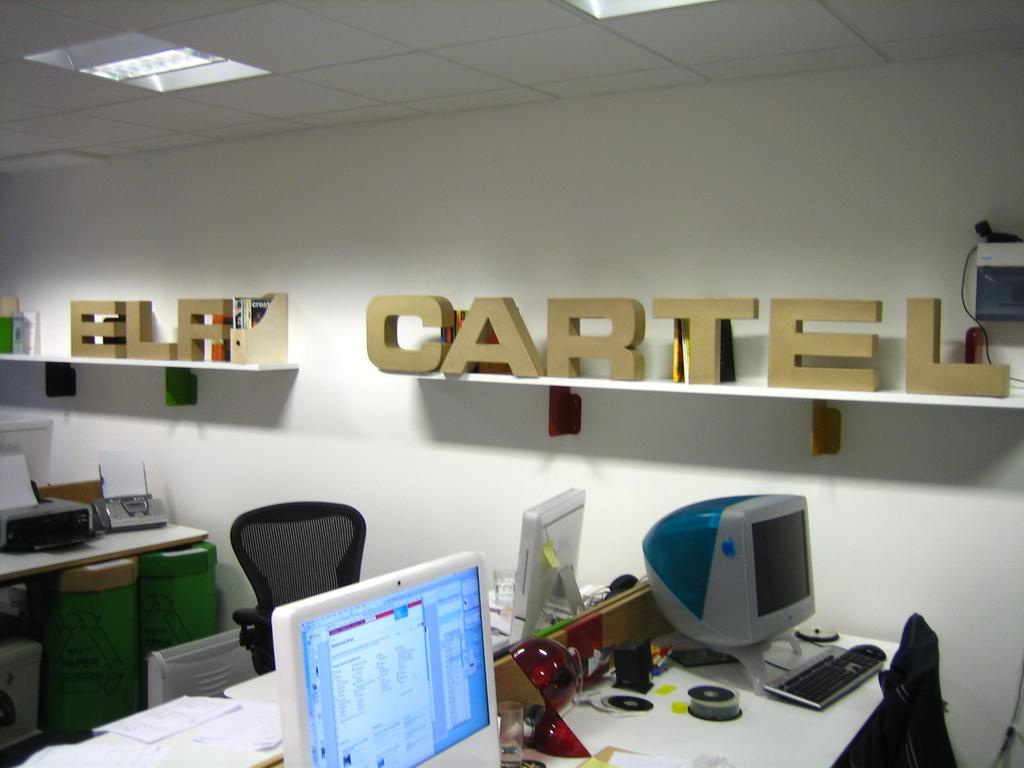<image>
Share a concise interpretation of the image provided. Inside office space with desks, computer monitors and a wall shelf with ELF CARTEL lettering. 